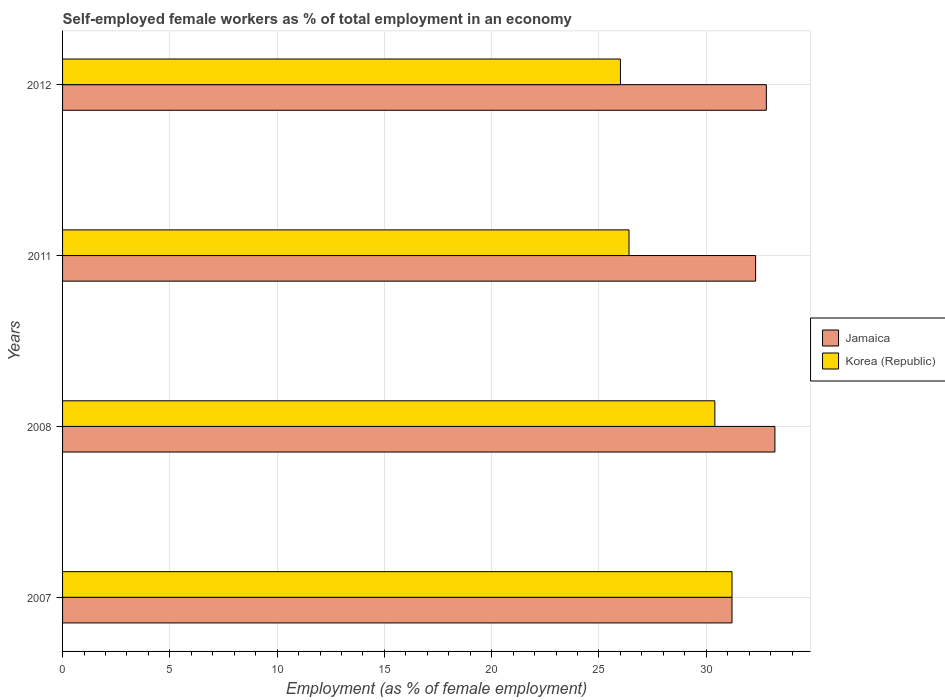How many different coloured bars are there?
Offer a very short reply. 2. How many bars are there on the 3rd tick from the bottom?
Your response must be concise. 2. What is the label of the 2nd group of bars from the top?
Offer a terse response. 2011. What is the percentage of self-employed female workers in Jamaica in 2011?
Offer a very short reply. 32.3. Across all years, what is the maximum percentage of self-employed female workers in Korea (Republic)?
Your response must be concise. 31.2. Across all years, what is the minimum percentage of self-employed female workers in Jamaica?
Offer a very short reply. 31.2. In which year was the percentage of self-employed female workers in Korea (Republic) minimum?
Offer a very short reply. 2012. What is the total percentage of self-employed female workers in Korea (Republic) in the graph?
Keep it short and to the point. 114. What is the difference between the percentage of self-employed female workers in Korea (Republic) in 2007 and that in 2008?
Offer a terse response. 0.8. What is the difference between the percentage of self-employed female workers in Jamaica in 2008 and the percentage of self-employed female workers in Korea (Republic) in 2012?
Provide a succinct answer. 7.2. What is the average percentage of self-employed female workers in Jamaica per year?
Your answer should be very brief. 32.38. In the year 2011, what is the difference between the percentage of self-employed female workers in Jamaica and percentage of self-employed female workers in Korea (Republic)?
Your response must be concise. 5.9. What is the ratio of the percentage of self-employed female workers in Korea (Republic) in 2011 to that in 2012?
Provide a short and direct response. 1.02. Is the difference between the percentage of self-employed female workers in Jamaica in 2007 and 2008 greater than the difference between the percentage of self-employed female workers in Korea (Republic) in 2007 and 2008?
Provide a short and direct response. No. What is the difference between the highest and the second highest percentage of self-employed female workers in Jamaica?
Provide a short and direct response. 0.4. What is the difference between the highest and the lowest percentage of self-employed female workers in Korea (Republic)?
Provide a short and direct response. 5.2. In how many years, is the percentage of self-employed female workers in Jamaica greater than the average percentage of self-employed female workers in Jamaica taken over all years?
Your answer should be compact. 2. Is the sum of the percentage of self-employed female workers in Korea (Republic) in 2008 and 2011 greater than the maximum percentage of self-employed female workers in Jamaica across all years?
Offer a very short reply. Yes. What does the 1st bar from the top in 2007 represents?
Your answer should be compact. Korea (Republic). What does the 1st bar from the bottom in 2007 represents?
Provide a succinct answer. Jamaica. Are all the bars in the graph horizontal?
Give a very brief answer. Yes. How many years are there in the graph?
Provide a short and direct response. 4. Does the graph contain grids?
Offer a terse response. Yes. How many legend labels are there?
Offer a very short reply. 2. What is the title of the graph?
Your answer should be very brief. Self-employed female workers as % of total employment in an economy. What is the label or title of the X-axis?
Provide a succinct answer. Employment (as % of female employment). What is the label or title of the Y-axis?
Keep it short and to the point. Years. What is the Employment (as % of female employment) of Jamaica in 2007?
Give a very brief answer. 31.2. What is the Employment (as % of female employment) in Korea (Republic) in 2007?
Offer a terse response. 31.2. What is the Employment (as % of female employment) in Jamaica in 2008?
Offer a very short reply. 33.2. What is the Employment (as % of female employment) in Korea (Republic) in 2008?
Your answer should be very brief. 30.4. What is the Employment (as % of female employment) of Jamaica in 2011?
Keep it short and to the point. 32.3. What is the Employment (as % of female employment) of Korea (Republic) in 2011?
Provide a short and direct response. 26.4. What is the Employment (as % of female employment) of Jamaica in 2012?
Give a very brief answer. 32.8. What is the Employment (as % of female employment) in Korea (Republic) in 2012?
Provide a succinct answer. 26. Across all years, what is the maximum Employment (as % of female employment) of Jamaica?
Provide a succinct answer. 33.2. Across all years, what is the maximum Employment (as % of female employment) in Korea (Republic)?
Your answer should be compact. 31.2. Across all years, what is the minimum Employment (as % of female employment) of Jamaica?
Your response must be concise. 31.2. What is the total Employment (as % of female employment) of Jamaica in the graph?
Make the answer very short. 129.5. What is the total Employment (as % of female employment) in Korea (Republic) in the graph?
Ensure brevity in your answer.  114. What is the difference between the Employment (as % of female employment) of Jamaica in 2007 and that in 2011?
Your answer should be compact. -1.1. What is the difference between the Employment (as % of female employment) in Korea (Republic) in 2007 and that in 2011?
Your answer should be very brief. 4.8. What is the difference between the Employment (as % of female employment) in Jamaica in 2008 and that in 2011?
Your answer should be very brief. 0.9. What is the difference between the Employment (as % of female employment) in Korea (Republic) in 2008 and that in 2011?
Your answer should be very brief. 4. What is the difference between the Employment (as % of female employment) in Jamaica in 2008 and that in 2012?
Keep it short and to the point. 0.4. What is the difference between the Employment (as % of female employment) of Korea (Republic) in 2008 and that in 2012?
Make the answer very short. 4.4. What is the difference between the Employment (as % of female employment) in Jamaica in 2011 and that in 2012?
Offer a terse response. -0.5. What is the difference between the Employment (as % of female employment) of Korea (Republic) in 2011 and that in 2012?
Provide a succinct answer. 0.4. What is the difference between the Employment (as % of female employment) of Jamaica in 2008 and the Employment (as % of female employment) of Korea (Republic) in 2011?
Give a very brief answer. 6.8. What is the average Employment (as % of female employment) of Jamaica per year?
Offer a very short reply. 32.38. What is the average Employment (as % of female employment) of Korea (Republic) per year?
Your response must be concise. 28.5. In the year 2008, what is the difference between the Employment (as % of female employment) of Jamaica and Employment (as % of female employment) of Korea (Republic)?
Give a very brief answer. 2.8. In the year 2011, what is the difference between the Employment (as % of female employment) in Jamaica and Employment (as % of female employment) in Korea (Republic)?
Give a very brief answer. 5.9. In the year 2012, what is the difference between the Employment (as % of female employment) of Jamaica and Employment (as % of female employment) of Korea (Republic)?
Your answer should be compact. 6.8. What is the ratio of the Employment (as % of female employment) of Jamaica in 2007 to that in 2008?
Give a very brief answer. 0.94. What is the ratio of the Employment (as % of female employment) in Korea (Republic) in 2007 to that in 2008?
Offer a terse response. 1.03. What is the ratio of the Employment (as % of female employment) of Jamaica in 2007 to that in 2011?
Your response must be concise. 0.97. What is the ratio of the Employment (as % of female employment) in Korea (Republic) in 2007 to that in 2011?
Keep it short and to the point. 1.18. What is the ratio of the Employment (as % of female employment) of Jamaica in 2007 to that in 2012?
Provide a short and direct response. 0.95. What is the ratio of the Employment (as % of female employment) in Korea (Republic) in 2007 to that in 2012?
Provide a succinct answer. 1.2. What is the ratio of the Employment (as % of female employment) in Jamaica in 2008 to that in 2011?
Offer a very short reply. 1.03. What is the ratio of the Employment (as % of female employment) of Korea (Republic) in 2008 to that in 2011?
Your answer should be compact. 1.15. What is the ratio of the Employment (as % of female employment) of Jamaica in 2008 to that in 2012?
Provide a succinct answer. 1.01. What is the ratio of the Employment (as % of female employment) of Korea (Republic) in 2008 to that in 2012?
Your answer should be very brief. 1.17. What is the ratio of the Employment (as % of female employment) of Korea (Republic) in 2011 to that in 2012?
Make the answer very short. 1.02. What is the difference between the highest and the second highest Employment (as % of female employment) of Korea (Republic)?
Give a very brief answer. 0.8. What is the difference between the highest and the lowest Employment (as % of female employment) in Jamaica?
Provide a succinct answer. 2. What is the difference between the highest and the lowest Employment (as % of female employment) in Korea (Republic)?
Ensure brevity in your answer.  5.2. 